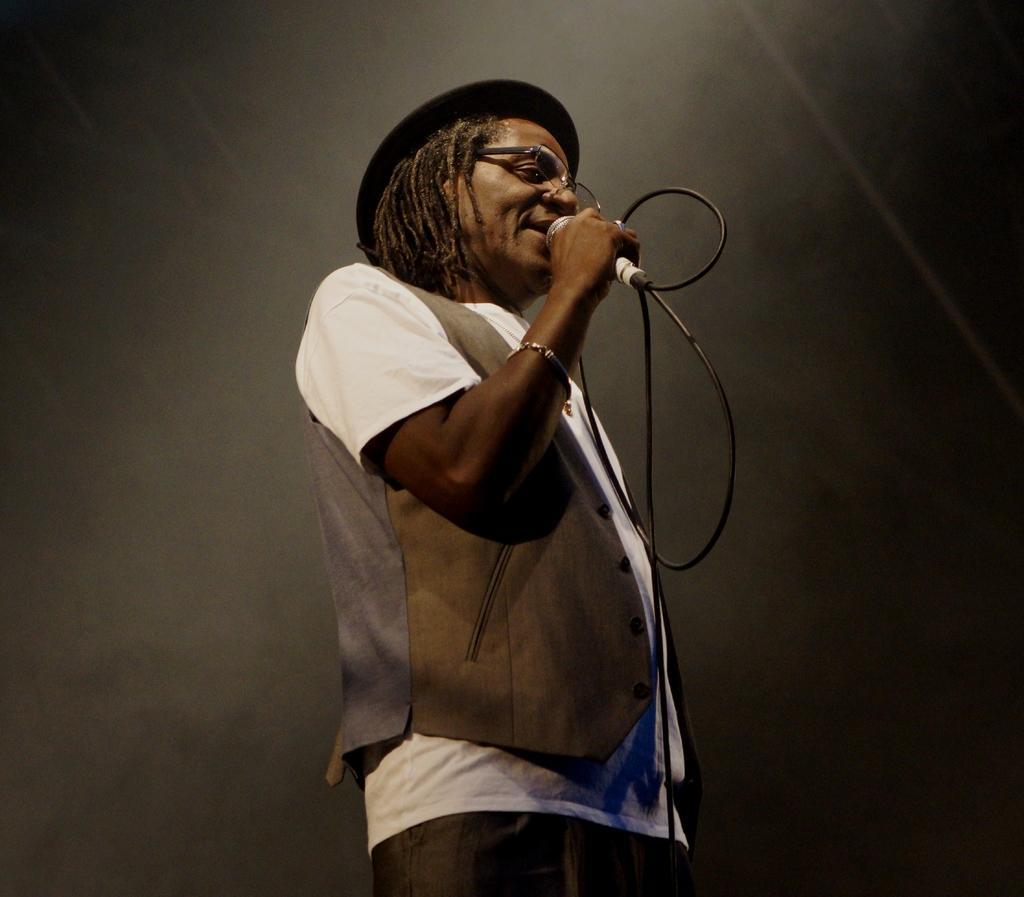Please provide a concise description of this image. In the middle of the image we can see a man, he is holding a microphone and we can see dark background. 